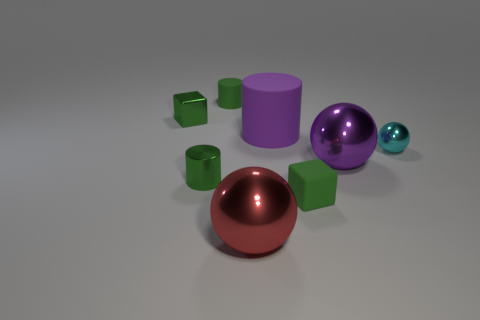The other cylinder that is the same color as the small rubber cylinder is what size?
Provide a succinct answer. Small. There is a large shiny thing that is the same color as the large matte cylinder; what is its shape?
Provide a short and direct response. Sphere. What number of brown metal things are the same size as the purple matte object?
Give a very brief answer. 0. The object that is in front of the small shiny cylinder and behind the red metallic sphere is what color?
Your response must be concise. Green. How many objects are tiny blue rubber things or small green blocks?
Provide a succinct answer. 2. What number of small objects are either shiny things or green metal cylinders?
Give a very brief answer. 3. Is there any other thing of the same color as the tiny sphere?
Make the answer very short. No. There is a thing that is on the left side of the red shiny sphere and in front of the purple cylinder; what size is it?
Offer a terse response. Small. There is a small cube that is on the left side of the green matte cylinder; does it have the same color as the matte thing that is in front of the cyan metallic ball?
Offer a very short reply. Yes. What number of other objects are the same material as the red ball?
Your answer should be compact. 4. 